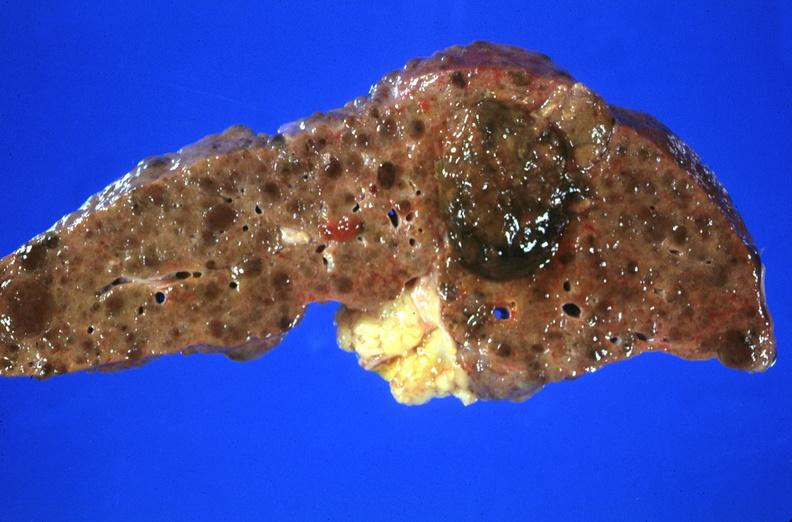what is present?
Answer the question using a single word or phrase. Hepatobiliary 